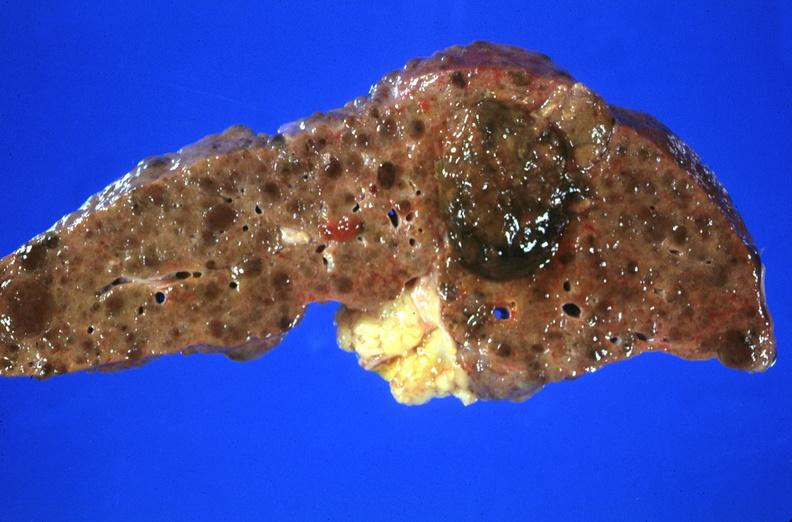what is present?
Answer the question using a single word or phrase. Hepatobiliary 